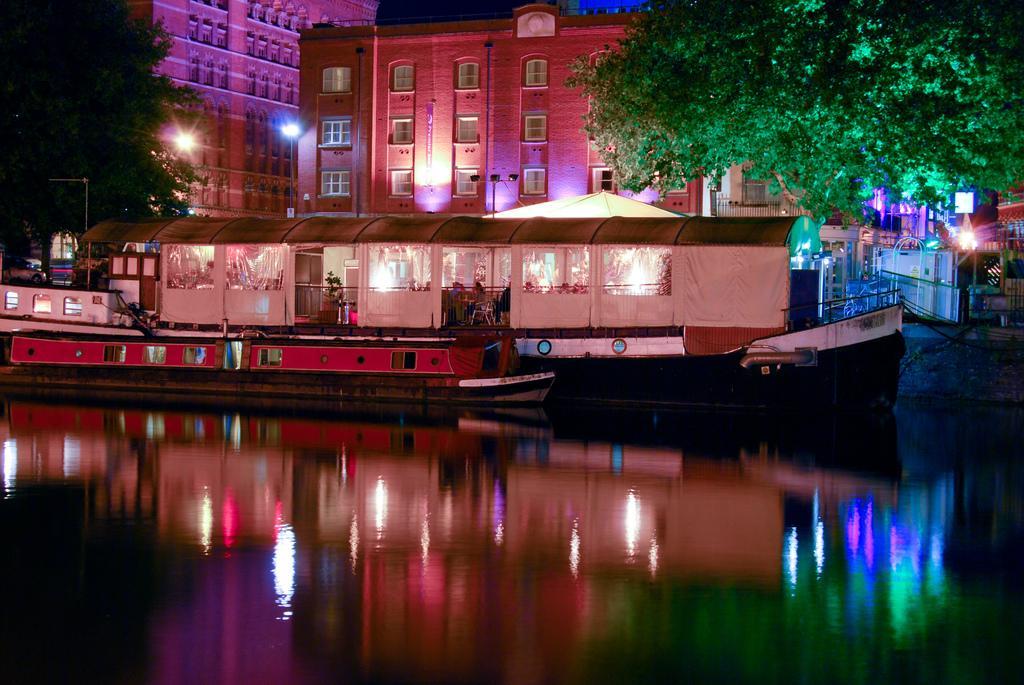Describe this image in one or two sentences. There are ships on the water and people are present inside it. There are trees and buildings at the back and there are colorful lights. 